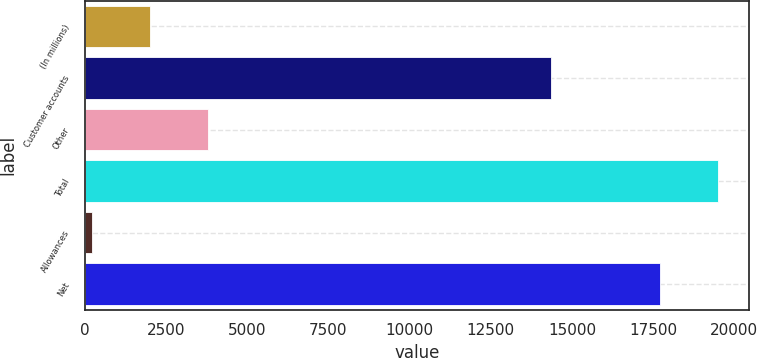Convert chart to OTSL. <chart><loc_0><loc_0><loc_500><loc_500><bar_chart><fcel>(In millions)<fcel>Customer accounts<fcel>Other<fcel>Total<fcel>Allowances<fcel>Net<nl><fcel>2018<fcel>14349<fcel>3789.1<fcel>19482.1<fcel>216<fcel>17711<nl></chart> 